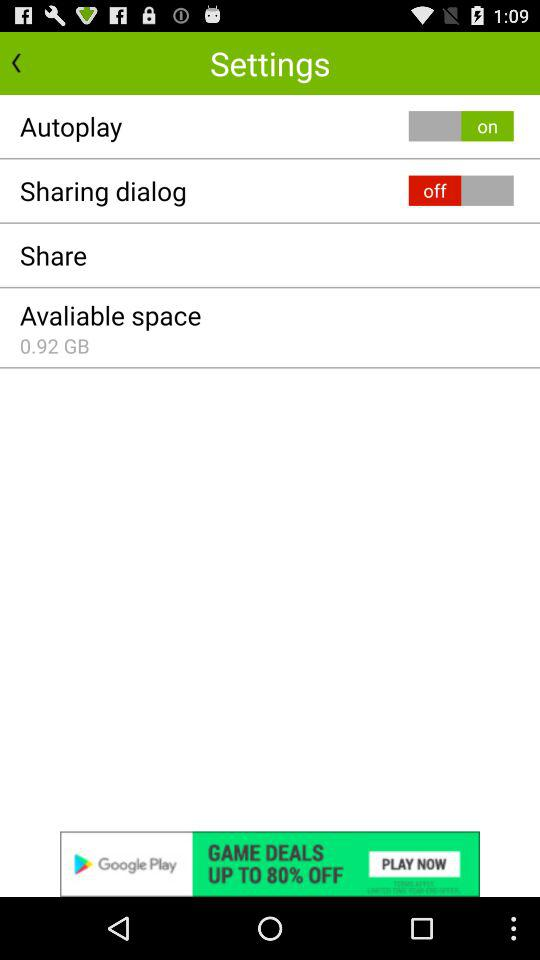What is the status of the "Sharing dialog"? The status is "off". 